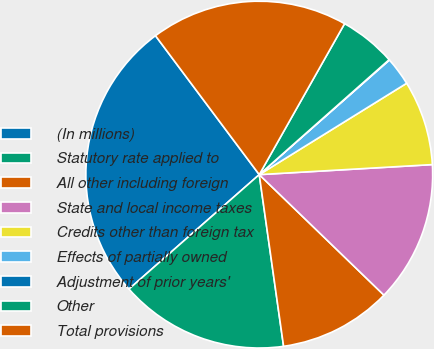<chart> <loc_0><loc_0><loc_500><loc_500><pie_chart><fcel>(In millions)<fcel>Statutory rate applied to<fcel>All other including foreign<fcel>State and local income taxes<fcel>Credits other than foreign tax<fcel>Effects of partially owned<fcel>Adjustment of prior years'<fcel>Other<fcel>Total provisions<nl><fcel>26.26%<fcel>15.77%<fcel>10.53%<fcel>13.15%<fcel>7.91%<fcel>2.66%<fcel>0.04%<fcel>5.28%<fcel>18.4%<nl></chart> 